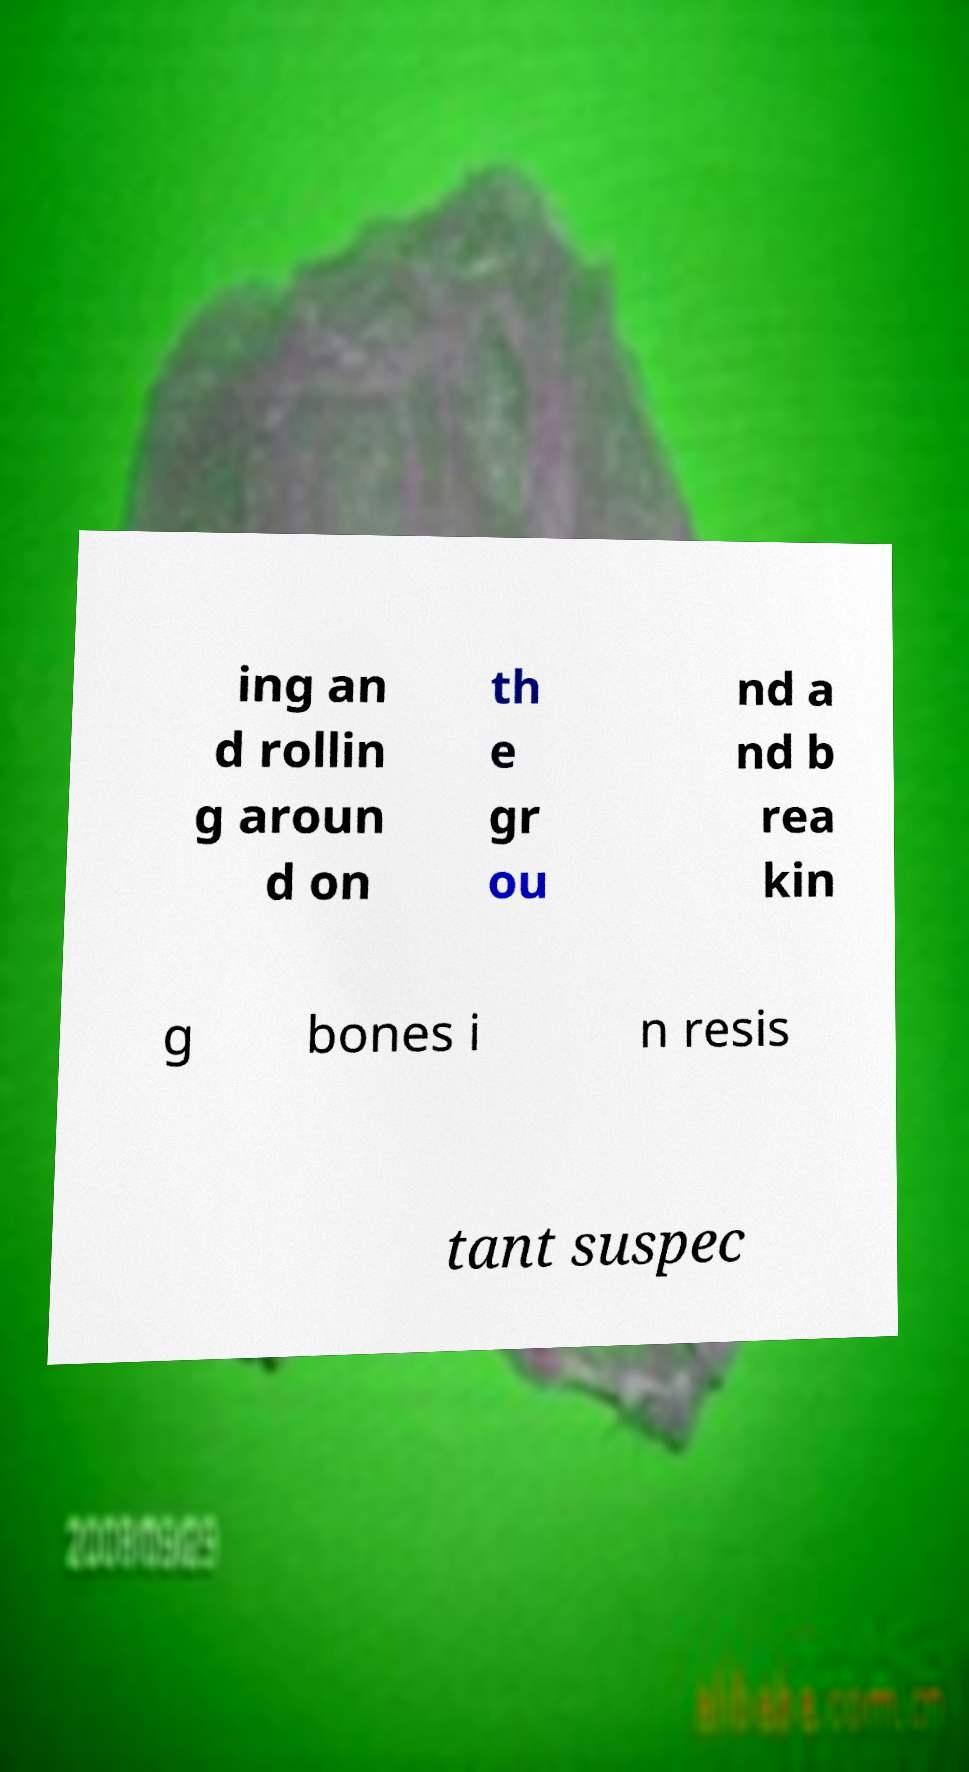Can you accurately transcribe the text from the provided image for me? ing an d rollin g aroun d on th e gr ou nd a nd b rea kin g bones i n resis tant suspec 